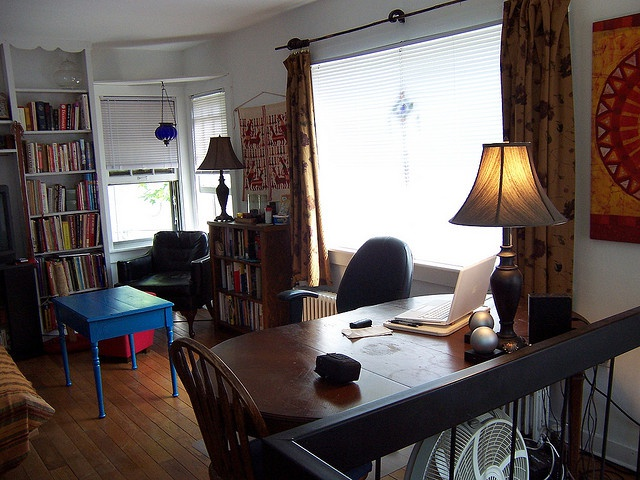Describe the objects in this image and their specific colors. I can see dining table in gray, black, lightgray, maroon, and darkgray tones, book in gray, black, and maroon tones, chair in gray, black, and maroon tones, chair in gray, black, and purple tones, and chair in gray, black, and white tones in this image. 